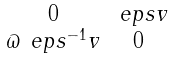<formula> <loc_0><loc_0><loc_500><loc_500>\begin{smallmatrix} 0 & \ e p s v \\ \varpi \ e p s ^ { - 1 } v & 0 \end{smallmatrix}</formula> 